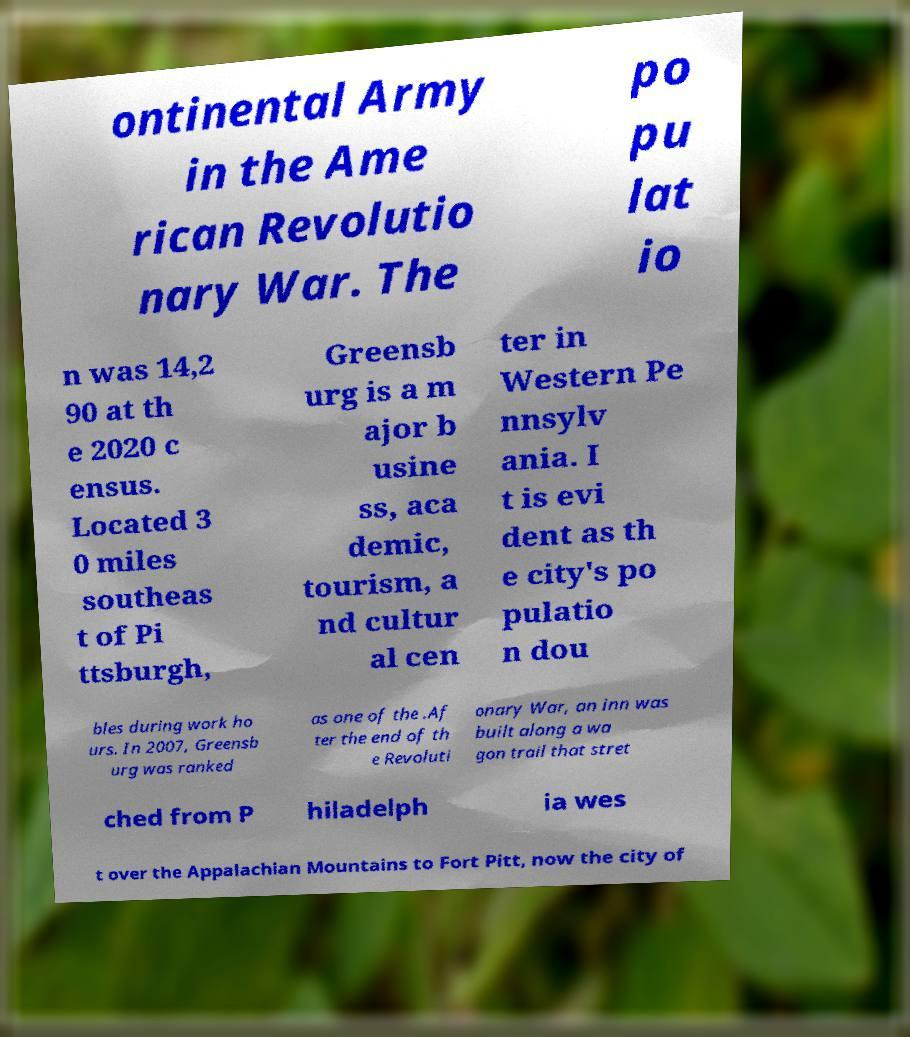Can you accurately transcribe the text from the provided image for me? ontinental Army in the Ame rican Revolutio nary War. The po pu lat io n was 14,2 90 at th e 2020 c ensus. Located 3 0 miles southeas t of Pi ttsburgh, Greensb urg is a m ajor b usine ss, aca demic, tourism, a nd cultur al cen ter in Western Pe nnsylv ania. I t is evi dent as th e city's po pulatio n dou bles during work ho urs. In 2007, Greensb urg was ranked as one of the .Af ter the end of th e Revoluti onary War, an inn was built along a wa gon trail that stret ched from P hiladelph ia wes t over the Appalachian Mountains to Fort Pitt, now the city of 